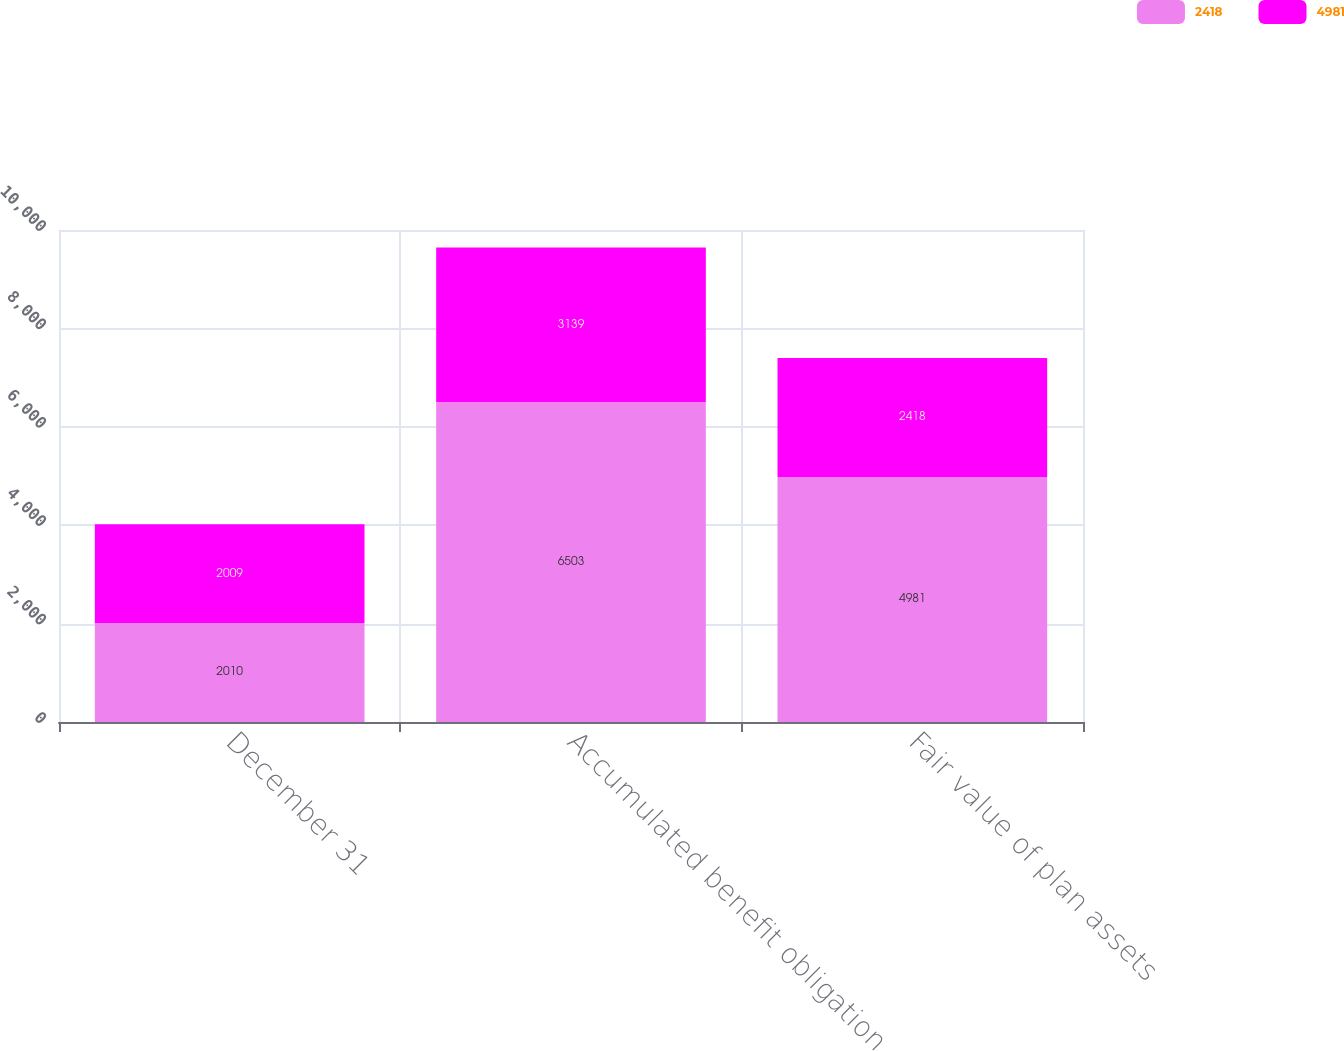Convert chart. <chart><loc_0><loc_0><loc_500><loc_500><stacked_bar_chart><ecel><fcel>December 31<fcel>Accumulated benefit obligation<fcel>Fair value of plan assets<nl><fcel>2418<fcel>2010<fcel>6503<fcel>4981<nl><fcel>4981<fcel>2009<fcel>3139<fcel>2418<nl></chart> 